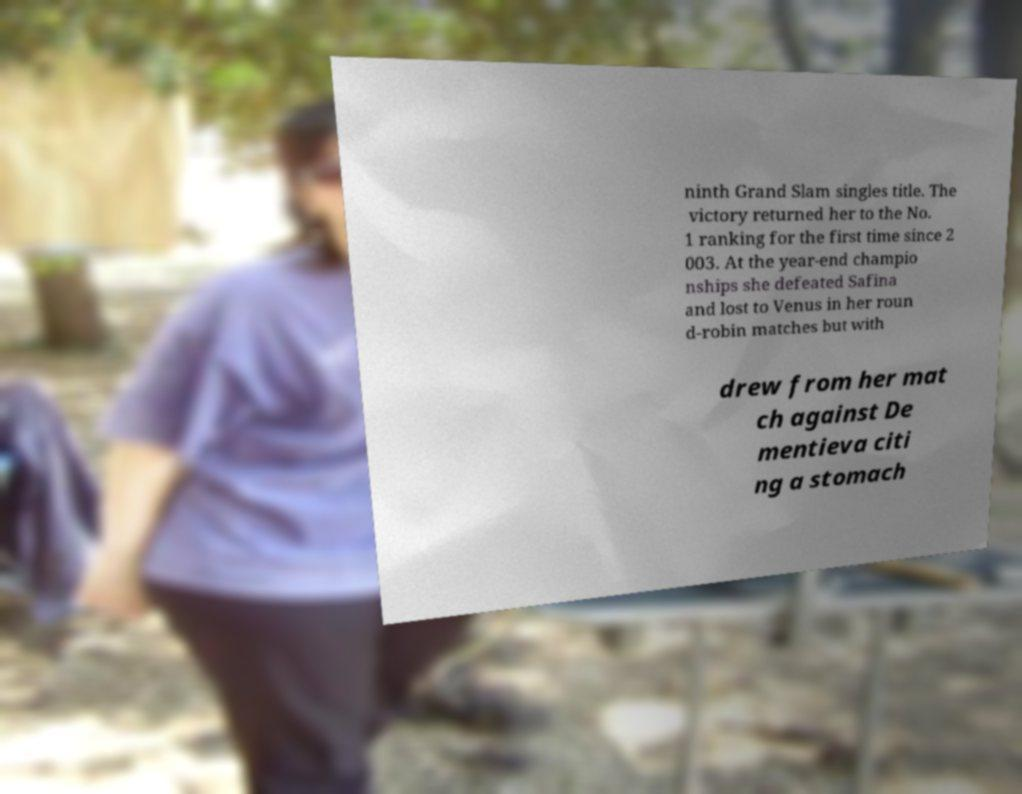Please read and relay the text visible in this image. What does it say? ninth Grand Slam singles title. The victory returned her to the No. 1 ranking for the first time since 2 003. At the year-end champio nships she defeated Safina and lost to Venus in her roun d-robin matches but with drew from her mat ch against De mentieva citi ng a stomach 